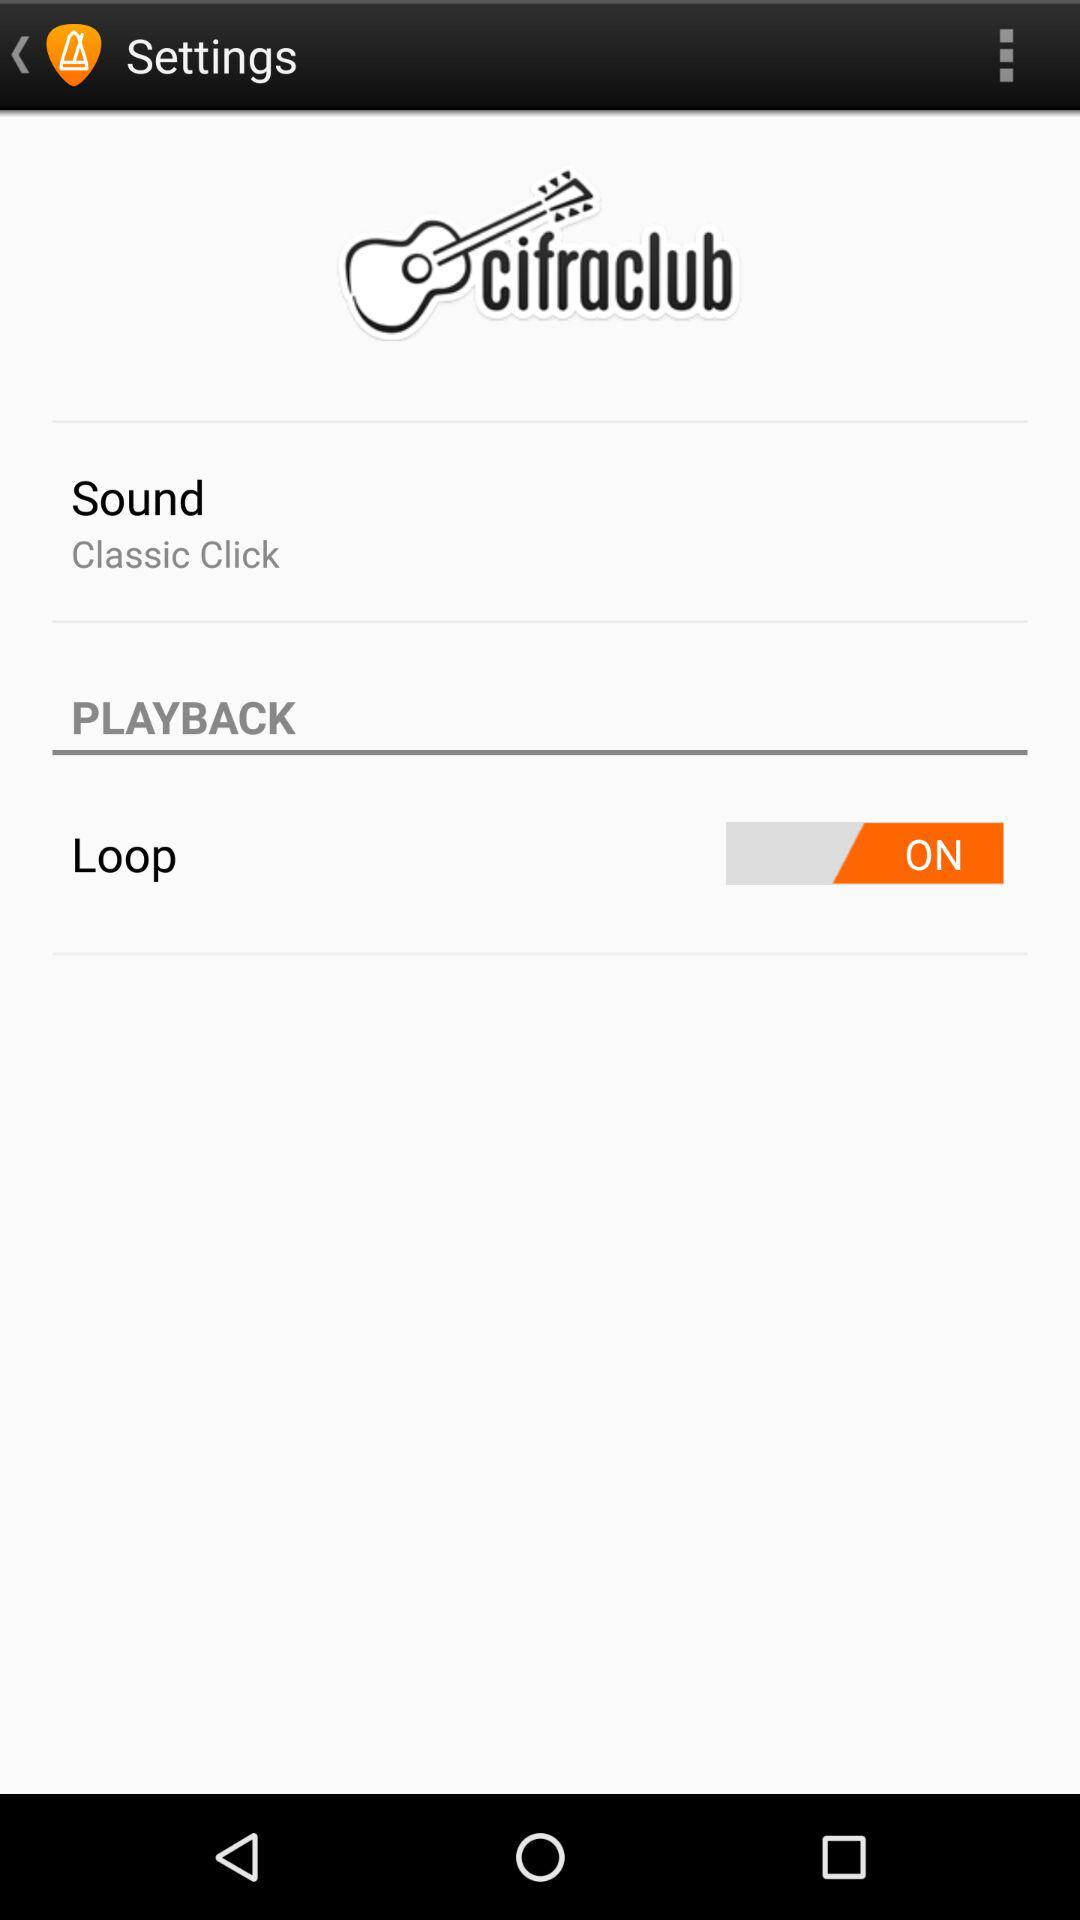What is the status of "Loop"? The status is "ON". 